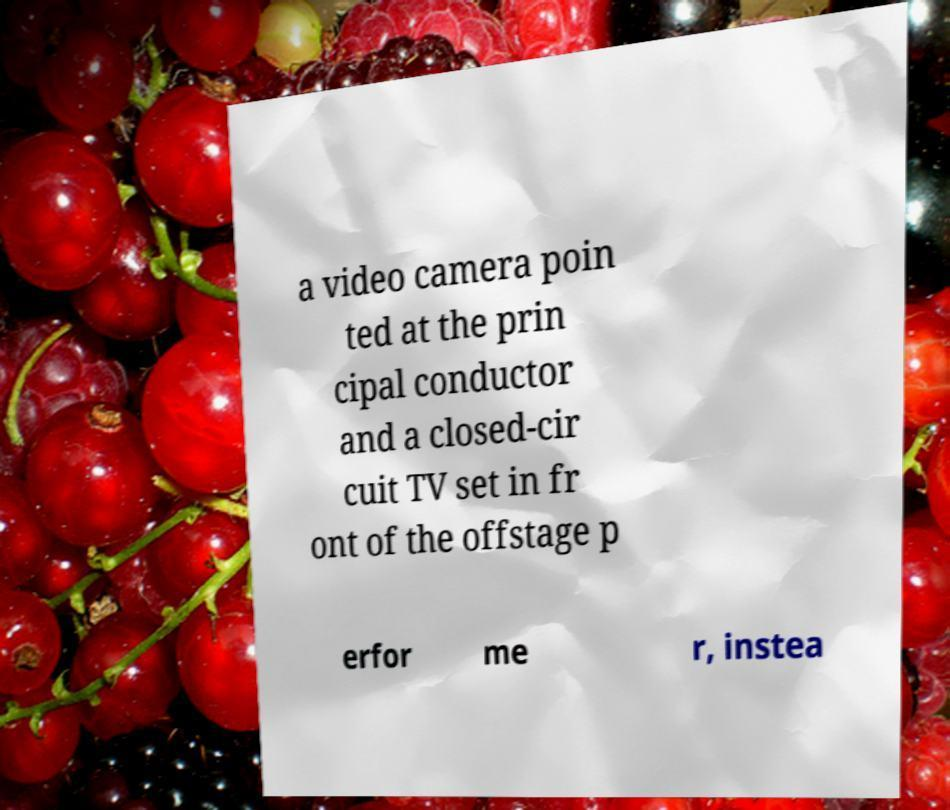There's text embedded in this image that I need extracted. Can you transcribe it verbatim? a video camera poin ted at the prin cipal conductor and a closed-cir cuit TV set in fr ont of the offstage p erfor me r, instea 